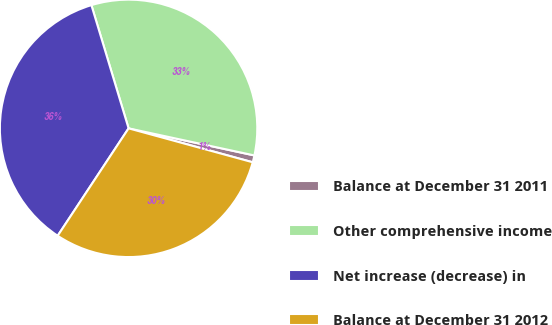Convert chart to OTSL. <chart><loc_0><loc_0><loc_500><loc_500><pie_chart><fcel>Balance at December 31 2011<fcel>Other comprehensive income<fcel>Net increase (decrease) in<fcel>Balance at December 31 2012<nl><fcel>0.87%<fcel>33.04%<fcel>36.05%<fcel>30.04%<nl></chart> 